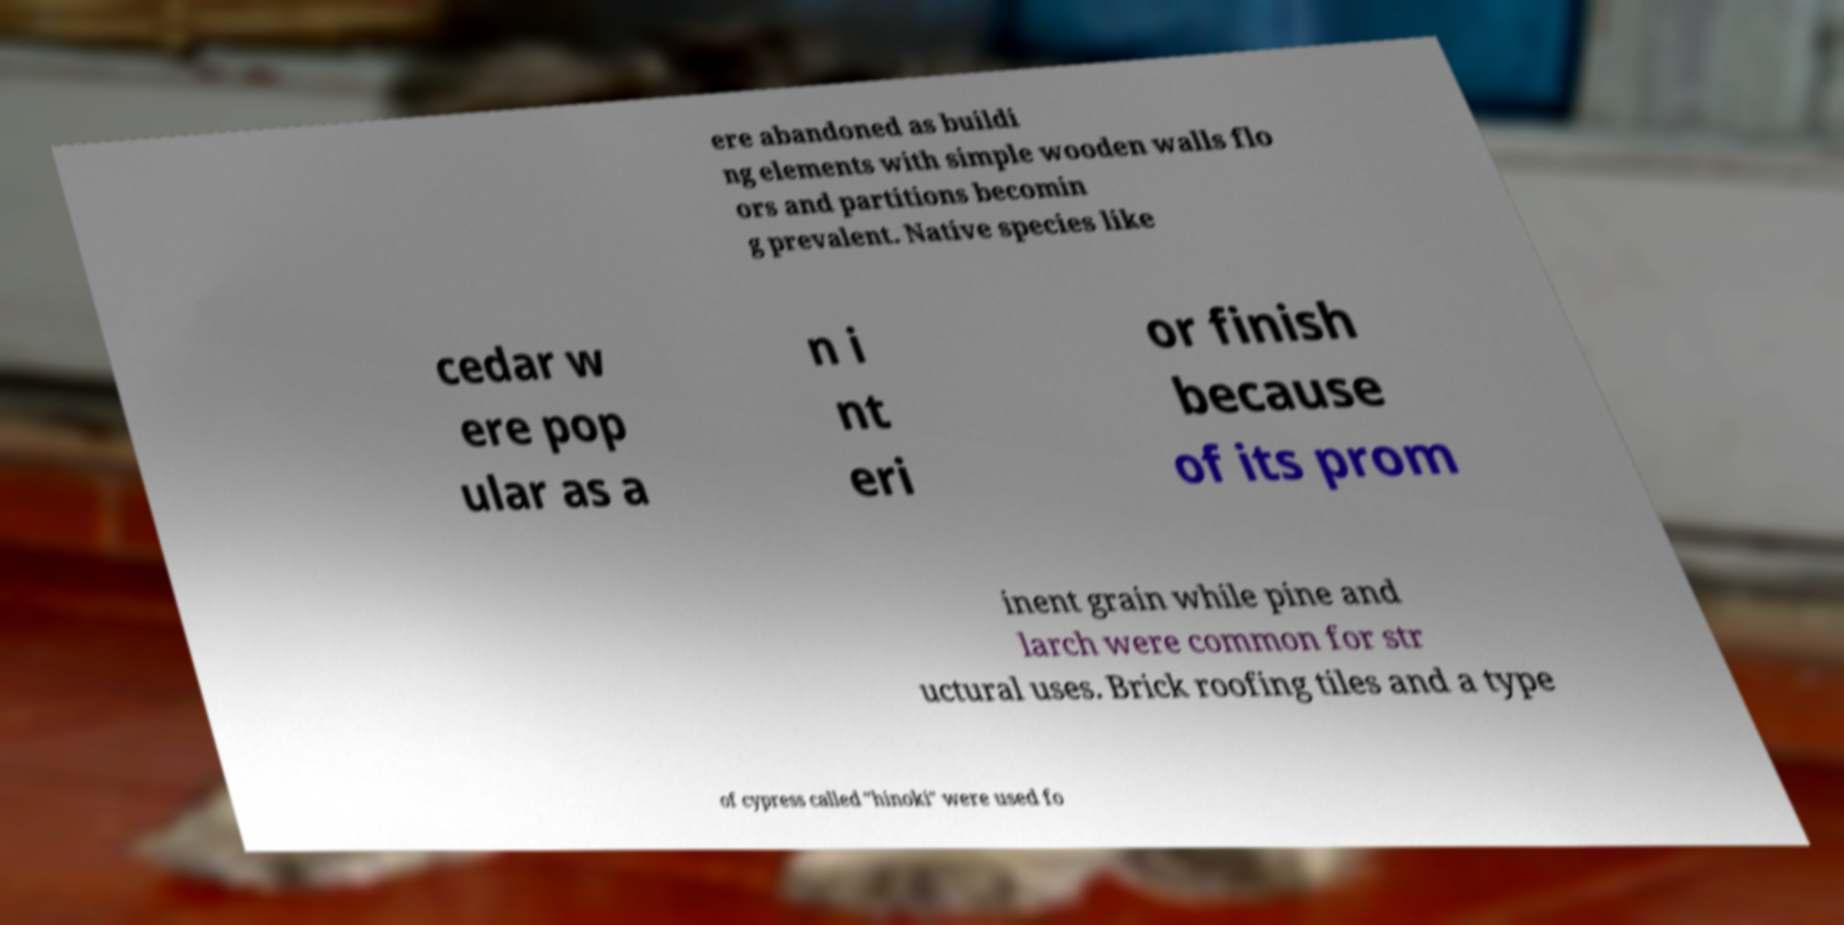Please read and relay the text visible in this image. What does it say? ere abandoned as buildi ng elements with simple wooden walls flo ors and partitions becomin g prevalent. Native species like cedar w ere pop ular as a n i nt eri or finish because of its prom inent grain while pine and larch were common for str uctural uses. Brick roofing tiles and a type of cypress called "hinoki" were used fo 